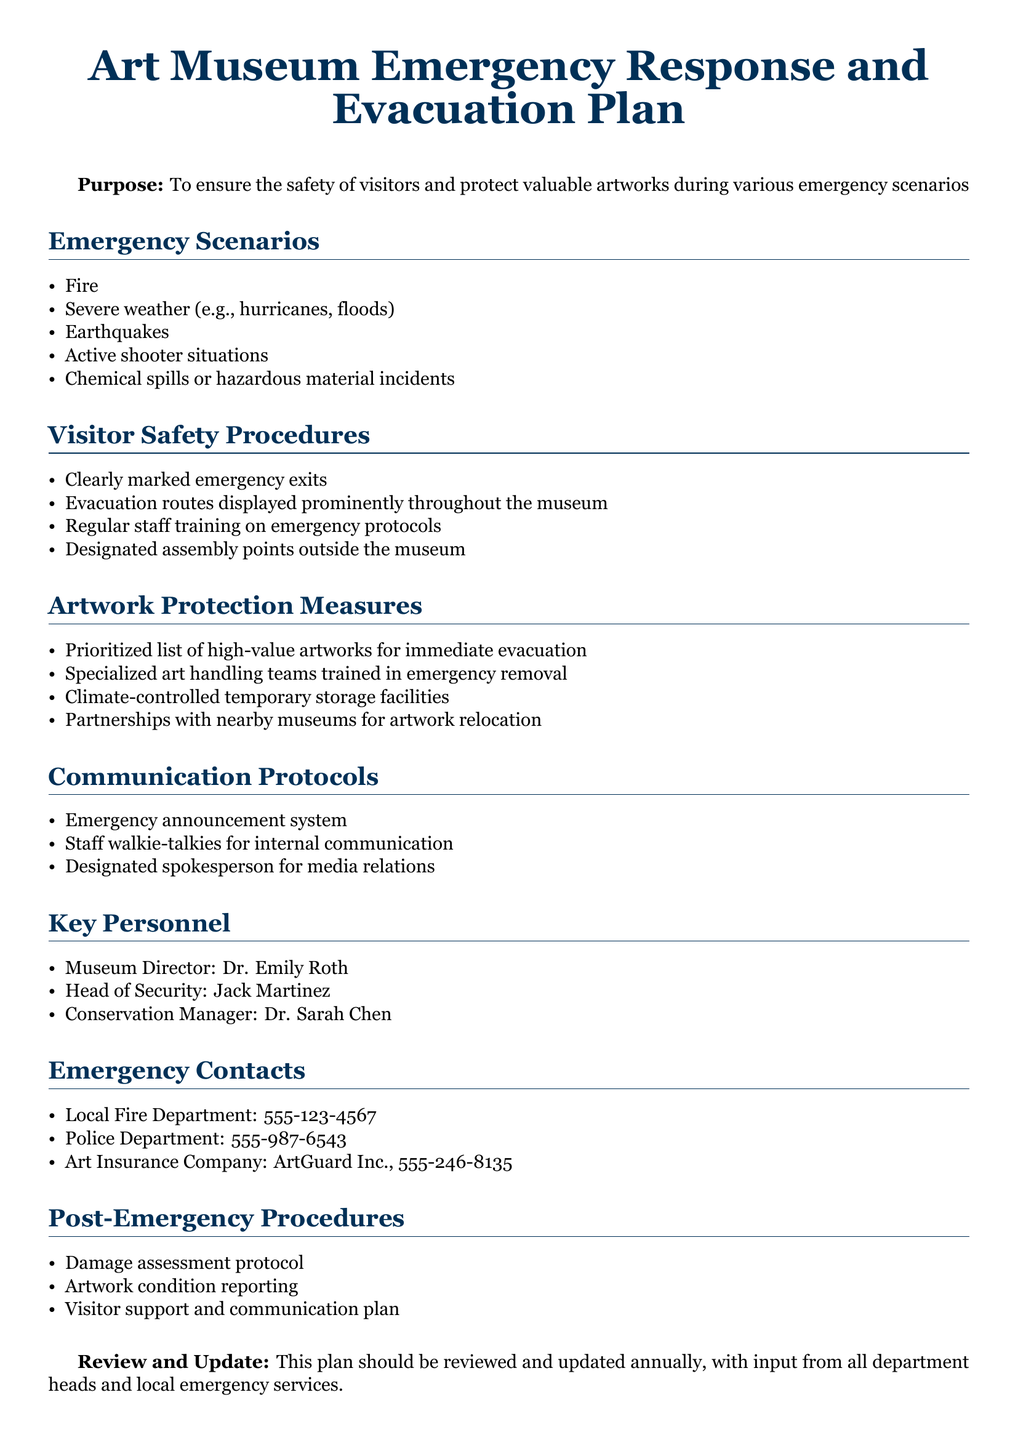What is the purpose of the plan? The purpose is to ensure the safety of visitors and protect valuable artworks during various emergency scenarios.
Answer: To ensure the safety of visitors and protect valuable artworks during various emergency scenarios How many emergency scenarios are listed? The document lists five distinct emergency scenarios under the Emergency Scenarios section.
Answer: 5 Who is the Head of Security? This person is the designated individual responsible for overseeing security during emergencies.
Answer: Jack Martinez What is one main communication method outlined in the document? The document mentions several methods of communication; one of them is the emergency announcement system.
Answer: Emergency announcement system Which staff member is responsible for conservation? This individual oversees the care of artworks in the museum during emergencies.
Answer: Dr. Sarah Chen What type of training do staff undergo according to the plan? This training is necessary for staff to effectively respond to emergency situations and protect visitors and artworks.
Answer: Regular staff training on emergency protocols What should be done after an emergency according to the plan? This procedure involves assessing any damage that occurred during the emergency to artworks or the museum.
Answer: Damage assessment protocol What is the name of the insurance company listed in the document? This company is mentioned as part of the emergency contact information for art insurance needs.
Answer: ArtGuard Inc How often should the plan be reviewed and updated? The plan's review schedule is designed to maintain its effectiveness in ensuring safety.
Answer: Annually 